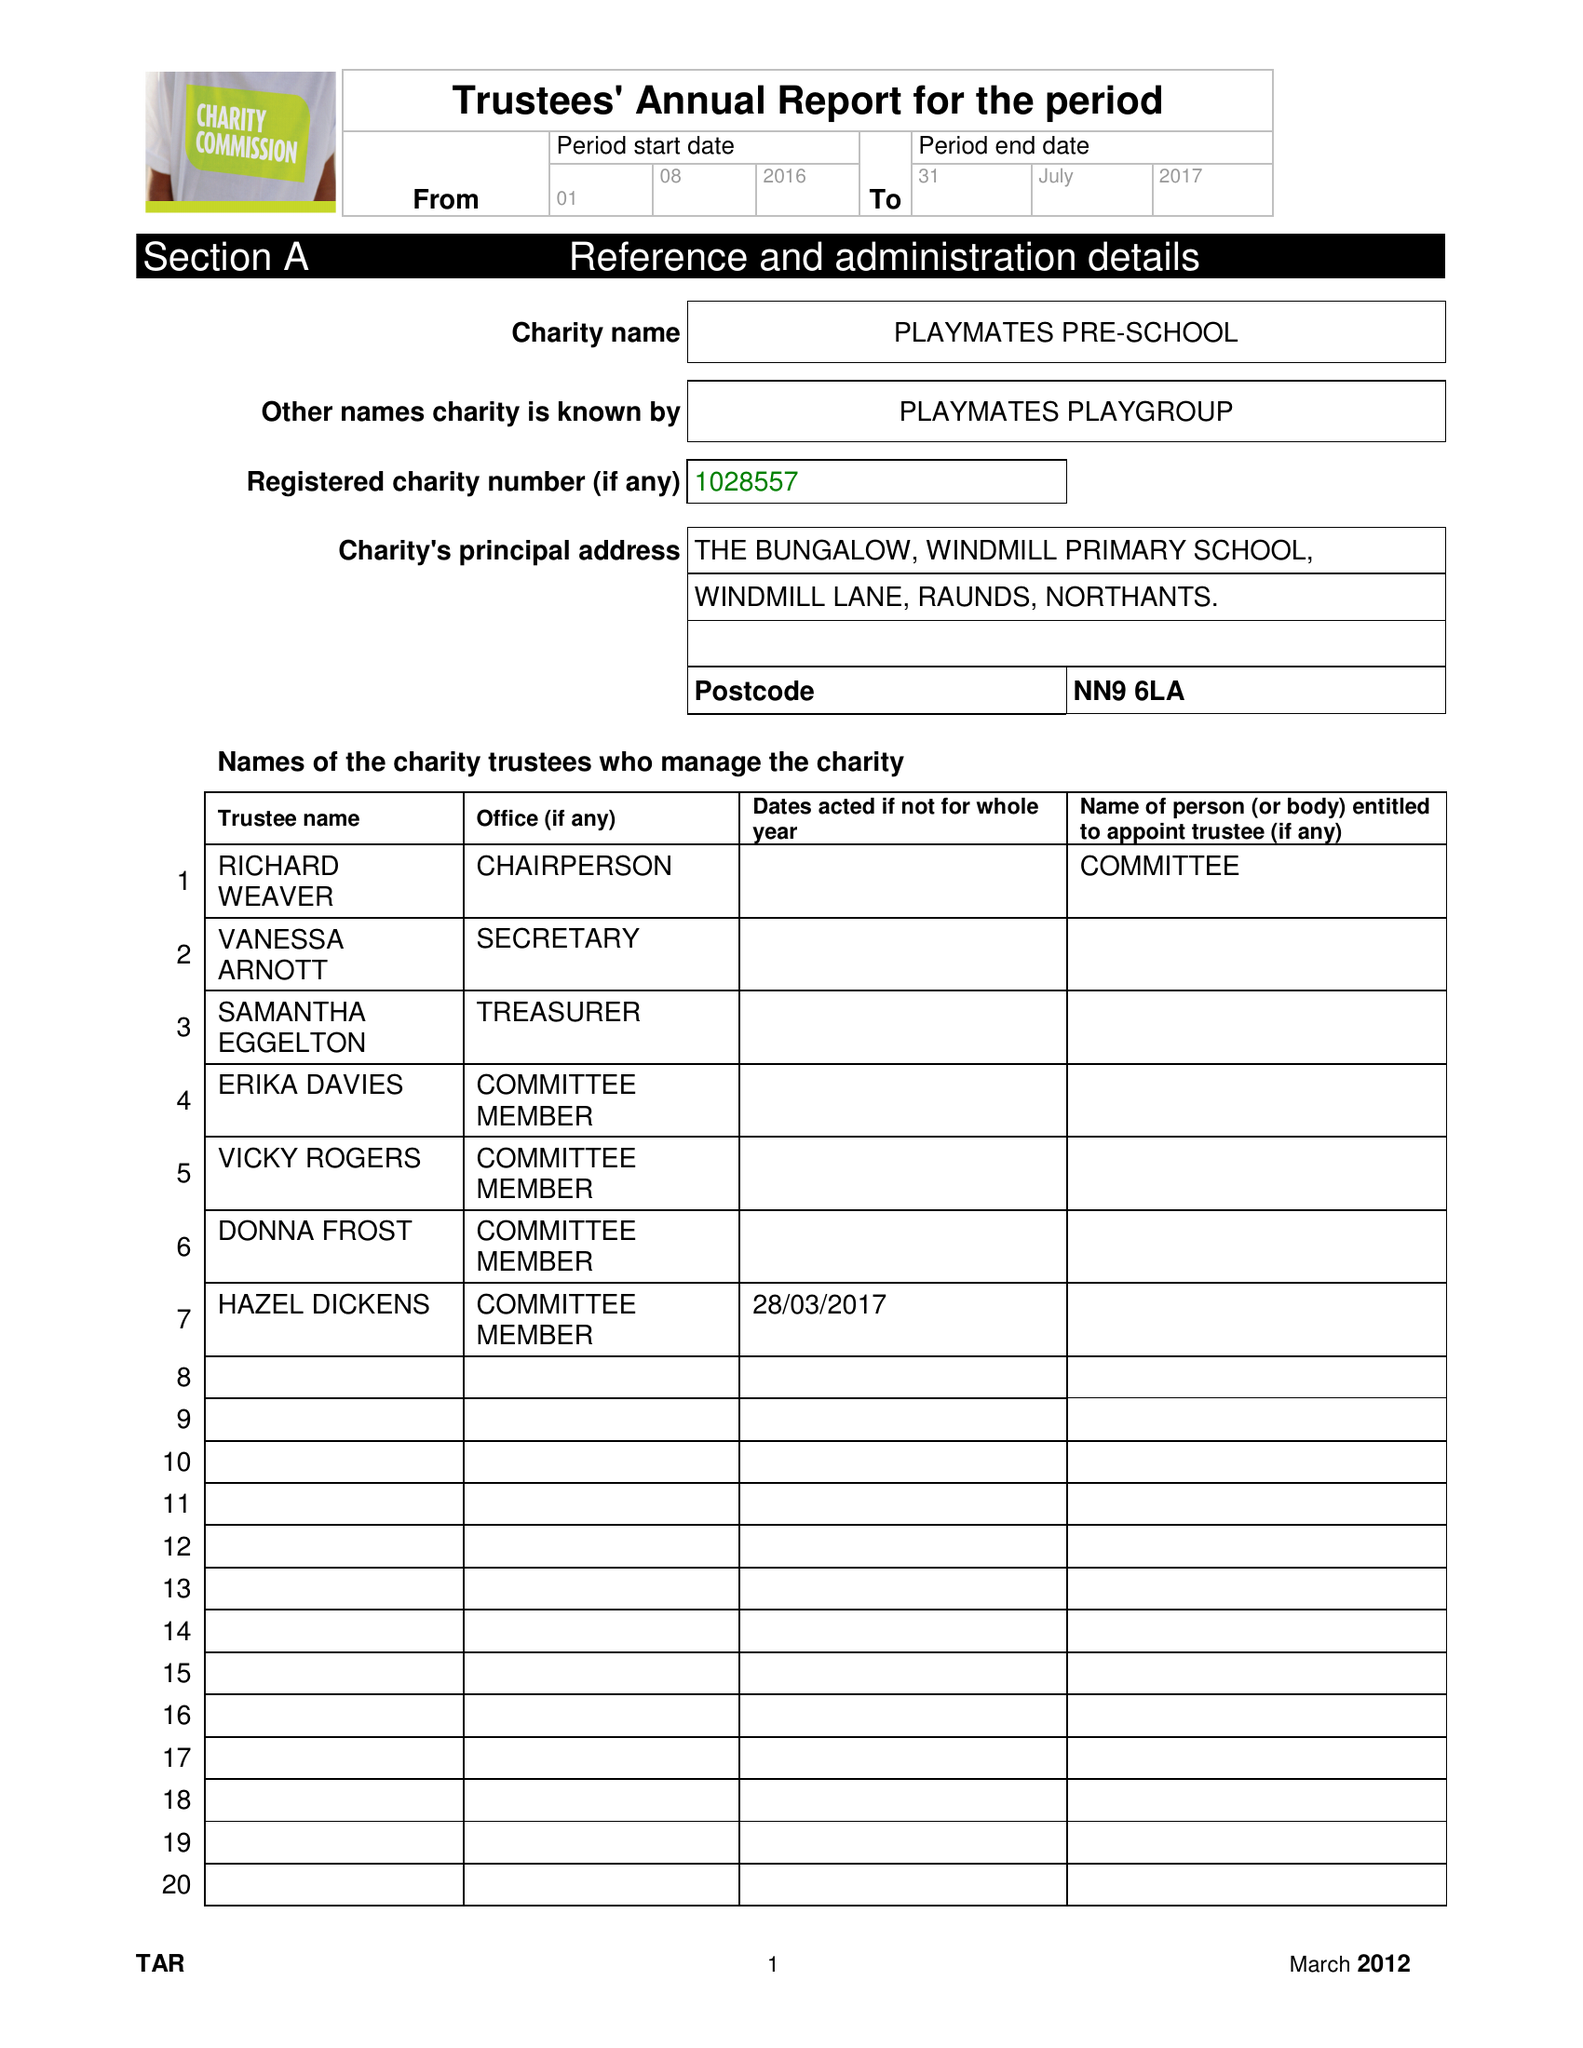What is the value for the income_annually_in_british_pounds?
Answer the question using a single word or phrase. 104355.16 